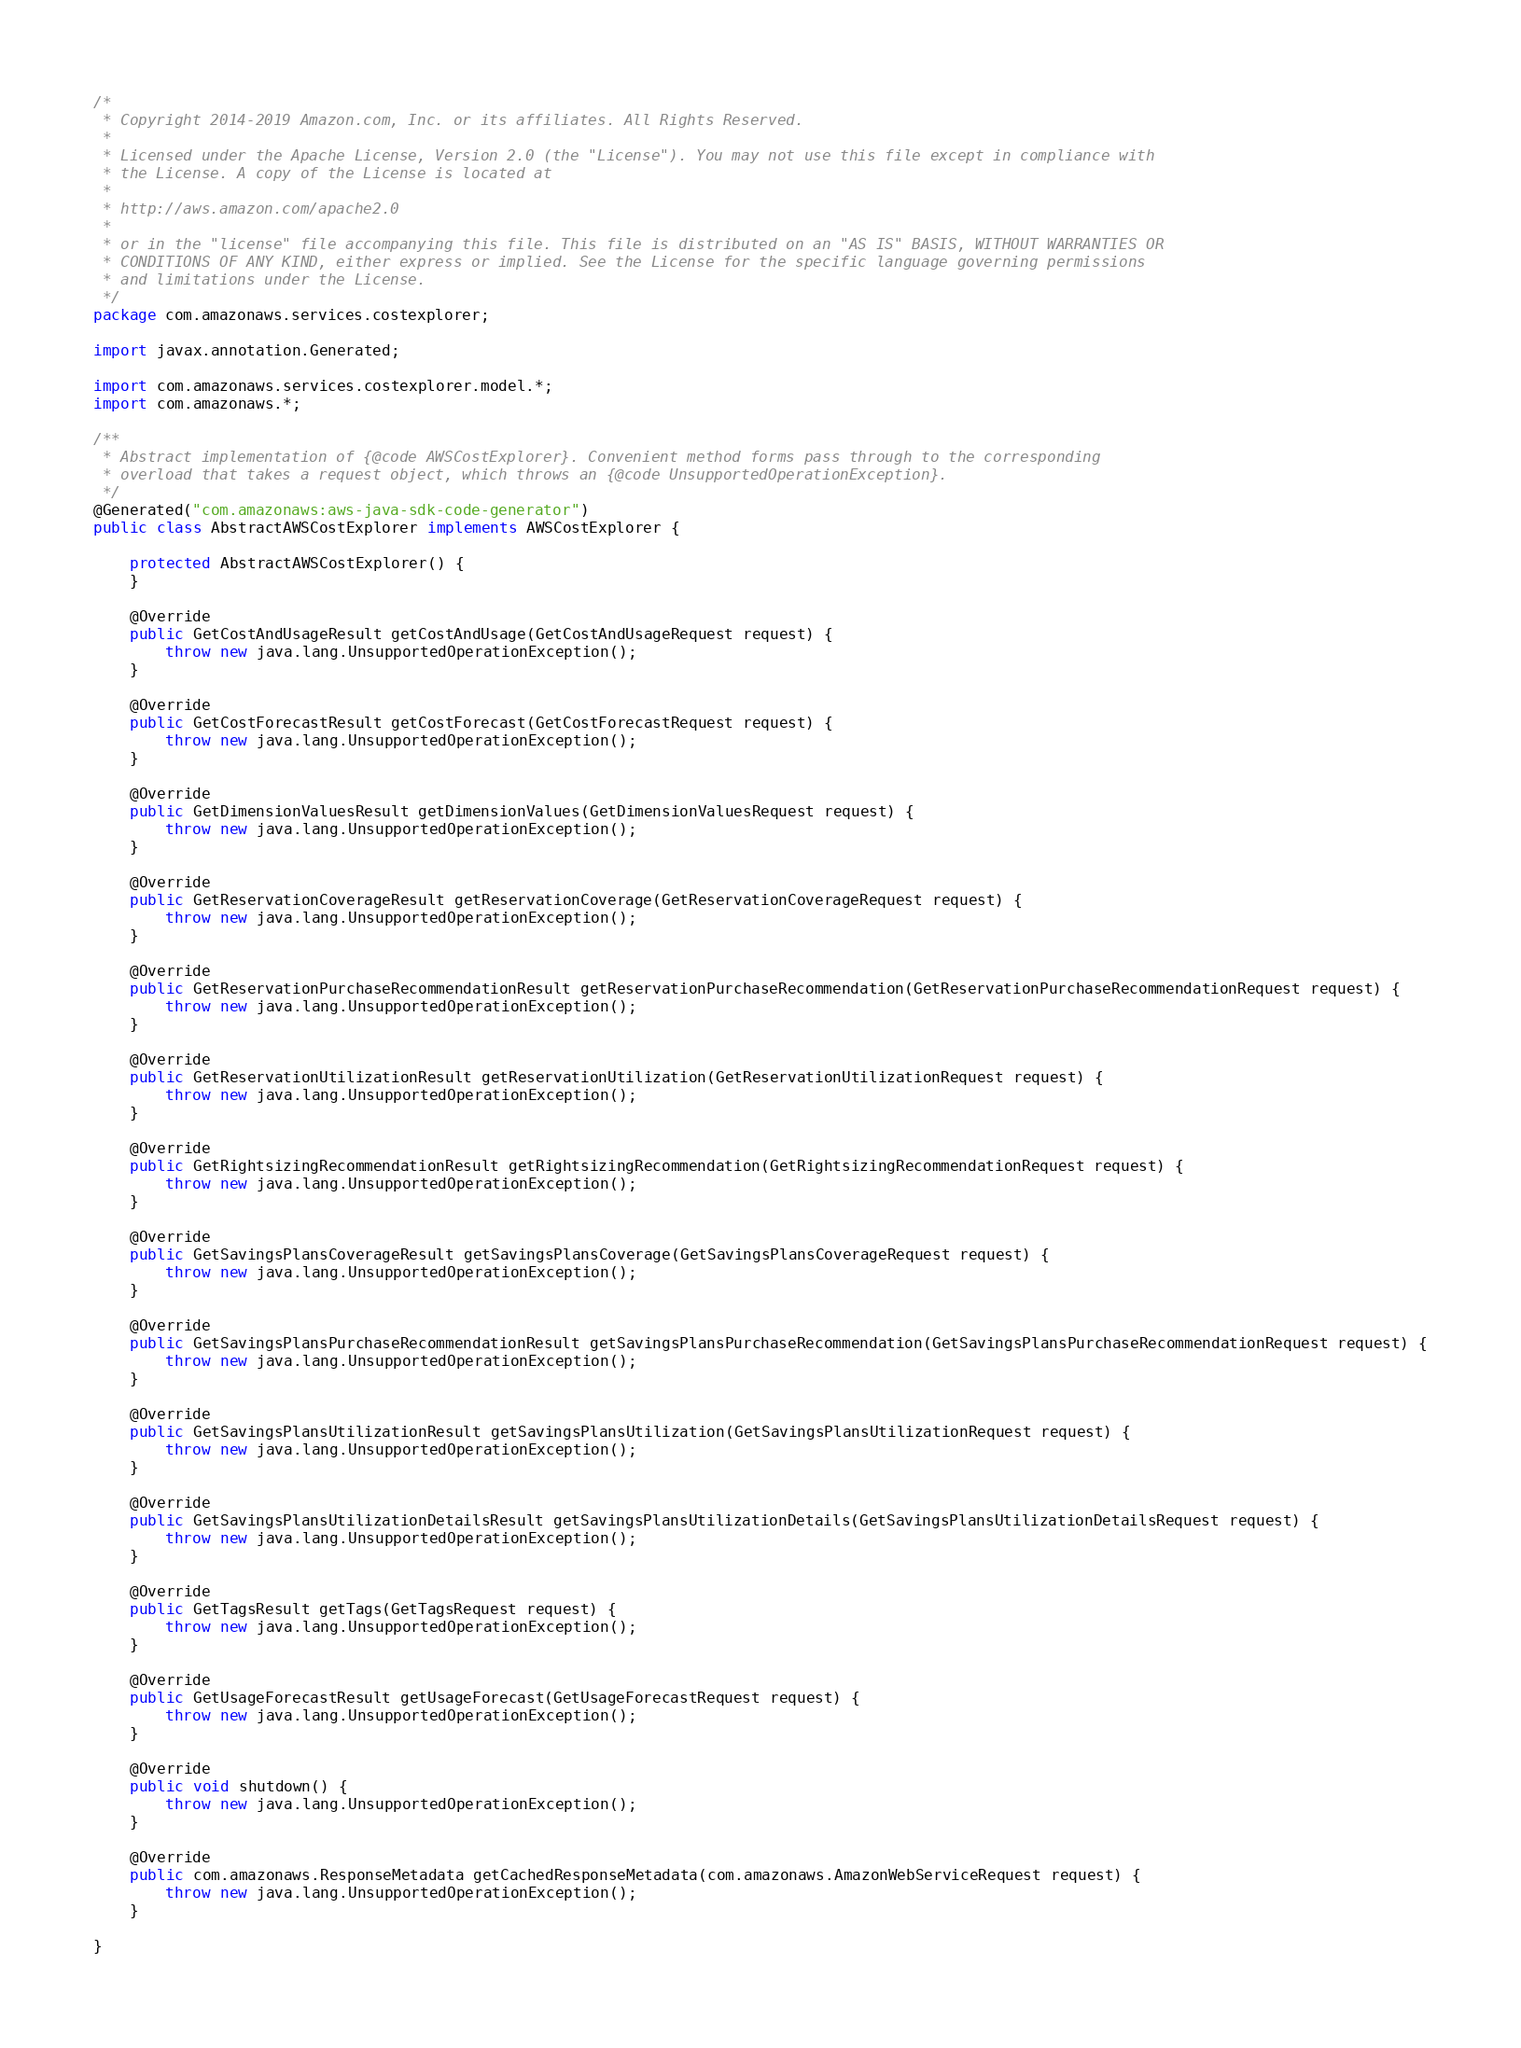Convert code to text. <code><loc_0><loc_0><loc_500><loc_500><_Java_>/*
 * Copyright 2014-2019 Amazon.com, Inc. or its affiliates. All Rights Reserved.
 * 
 * Licensed under the Apache License, Version 2.0 (the "License"). You may not use this file except in compliance with
 * the License. A copy of the License is located at
 * 
 * http://aws.amazon.com/apache2.0
 * 
 * or in the "license" file accompanying this file. This file is distributed on an "AS IS" BASIS, WITHOUT WARRANTIES OR
 * CONDITIONS OF ANY KIND, either express or implied. See the License for the specific language governing permissions
 * and limitations under the License.
 */
package com.amazonaws.services.costexplorer;

import javax.annotation.Generated;

import com.amazonaws.services.costexplorer.model.*;
import com.amazonaws.*;

/**
 * Abstract implementation of {@code AWSCostExplorer}. Convenient method forms pass through to the corresponding
 * overload that takes a request object, which throws an {@code UnsupportedOperationException}.
 */
@Generated("com.amazonaws:aws-java-sdk-code-generator")
public class AbstractAWSCostExplorer implements AWSCostExplorer {

    protected AbstractAWSCostExplorer() {
    }

    @Override
    public GetCostAndUsageResult getCostAndUsage(GetCostAndUsageRequest request) {
        throw new java.lang.UnsupportedOperationException();
    }

    @Override
    public GetCostForecastResult getCostForecast(GetCostForecastRequest request) {
        throw new java.lang.UnsupportedOperationException();
    }

    @Override
    public GetDimensionValuesResult getDimensionValues(GetDimensionValuesRequest request) {
        throw new java.lang.UnsupportedOperationException();
    }

    @Override
    public GetReservationCoverageResult getReservationCoverage(GetReservationCoverageRequest request) {
        throw new java.lang.UnsupportedOperationException();
    }

    @Override
    public GetReservationPurchaseRecommendationResult getReservationPurchaseRecommendation(GetReservationPurchaseRecommendationRequest request) {
        throw new java.lang.UnsupportedOperationException();
    }

    @Override
    public GetReservationUtilizationResult getReservationUtilization(GetReservationUtilizationRequest request) {
        throw new java.lang.UnsupportedOperationException();
    }

    @Override
    public GetRightsizingRecommendationResult getRightsizingRecommendation(GetRightsizingRecommendationRequest request) {
        throw new java.lang.UnsupportedOperationException();
    }

    @Override
    public GetSavingsPlansCoverageResult getSavingsPlansCoverage(GetSavingsPlansCoverageRequest request) {
        throw new java.lang.UnsupportedOperationException();
    }

    @Override
    public GetSavingsPlansPurchaseRecommendationResult getSavingsPlansPurchaseRecommendation(GetSavingsPlansPurchaseRecommendationRequest request) {
        throw new java.lang.UnsupportedOperationException();
    }

    @Override
    public GetSavingsPlansUtilizationResult getSavingsPlansUtilization(GetSavingsPlansUtilizationRequest request) {
        throw new java.lang.UnsupportedOperationException();
    }

    @Override
    public GetSavingsPlansUtilizationDetailsResult getSavingsPlansUtilizationDetails(GetSavingsPlansUtilizationDetailsRequest request) {
        throw new java.lang.UnsupportedOperationException();
    }

    @Override
    public GetTagsResult getTags(GetTagsRequest request) {
        throw new java.lang.UnsupportedOperationException();
    }

    @Override
    public GetUsageForecastResult getUsageForecast(GetUsageForecastRequest request) {
        throw new java.lang.UnsupportedOperationException();
    }

    @Override
    public void shutdown() {
        throw new java.lang.UnsupportedOperationException();
    }

    @Override
    public com.amazonaws.ResponseMetadata getCachedResponseMetadata(com.amazonaws.AmazonWebServiceRequest request) {
        throw new java.lang.UnsupportedOperationException();
    }

}
</code> 